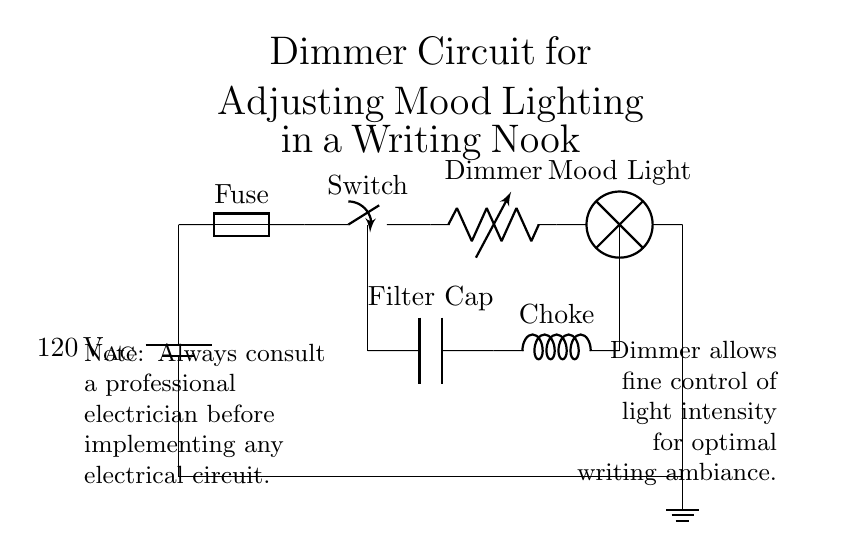What is the power source in this circuit? The power source is a battery labeled as 120 voltage AC, indicating it supplies alternating current to the circuit.
Answer: 120 voltage AC What component serves to protect the circuit? The fuse is included in the circuit to protect it from excessive current, thus preventing damage to the other components.
Answer: Fuse How does the dimmer affect the lamp? The dimmer, represented as a variable resistor, allows for the adjustment of resistance in the circuit, which in turn controls the current flowing to the lamp, allowing for mood lighting adjustments.
Answer: Controls current flow to lamp What is the purpose of the capacitor in the circuit? The filter capacitor smooths out voltage fluctuations, ensuring a steady flow of electricity to connected components and enhancing performance.
Answer: Smooths voltage fluctuations How many main components are there in the circuit? The circuit has five main components: the power source, fuse, switch, dimmer, and lamp.
Answer: Five What does the note regarding consulting a professional electrician imply? The note emphasizes the importance of safety and expertise when dealing with electrical circuits, indicating that improper implementation can lead to hazards.
Answer: Safety reminder 